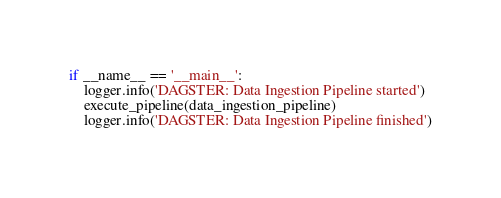Convert code to text. <code><loc_0><loc_0><loc_500><loc_500><_Python_>
if __name__ == '__main__':
    logger.info('DAGSTER: Data Ingestion Pipeline started')
    execute_pipeline(data_ingestion_pipeline)
    logger.info('DAGSTER: Data Ingestion Pipeline finished')</code> 